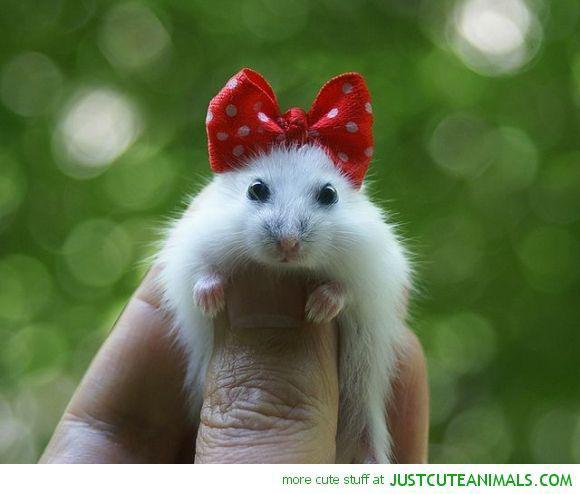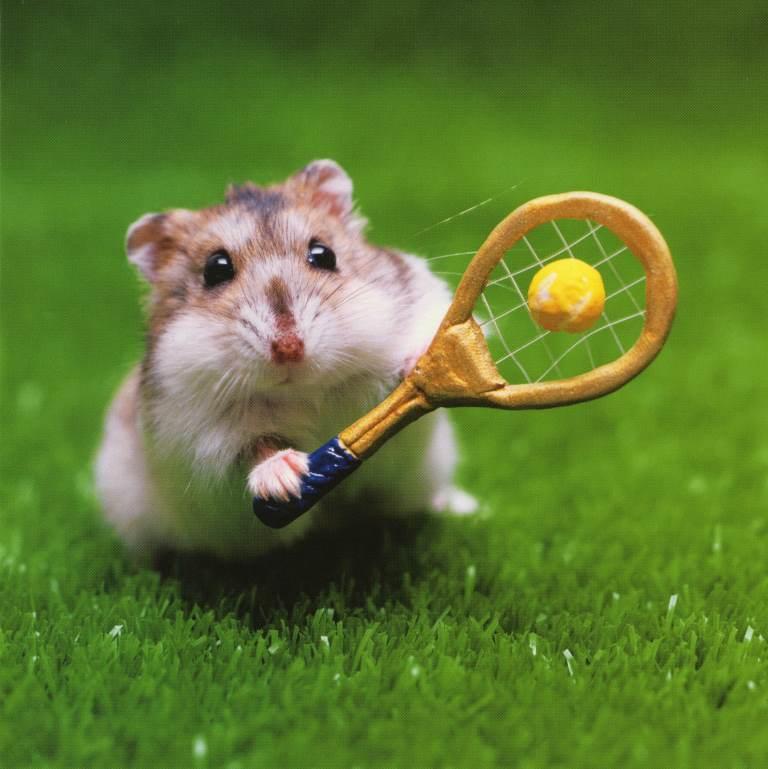The first image is the image on the left, the second image is the image on the right. Assess this claim about the two images: "A small rodent is holding a tennis racket.". Correct or not? Answer yes or no. Yes. The first image is the image on the left, the second image is the image on the right. Evaluate the accuracy of this statement regarding the images: "There is a hamster holding a tennis racket.". Is it true? Answer yes or no. Yes. 